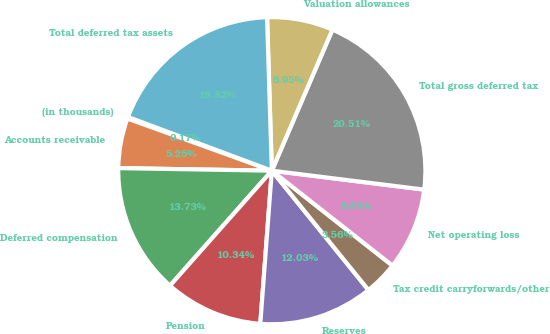Convert chart. <chart><loc_0><loc_0><loc_500><loc_500><pie_chart><fcel>(in thousands)<fcel>Accounts receivable<fcel>Deferred compensation<fcel>Pension<fcel>Reserves<fcel>Tax credit carryforwards/other<fcel>Net operating loss<fcel>Total gross deferred tax<fcel>Valuation allowances<fcel>Total deferred tax assets<nl><fcel>0.17%<fcel>5.25%<fcel>13.73%<fcel>10.34%<fcel>12.03%<fcel>3.56%<fcel>8.64%<fcel>20.51%<fcel>6.95%<fcel>18.82%<nl></chart> 